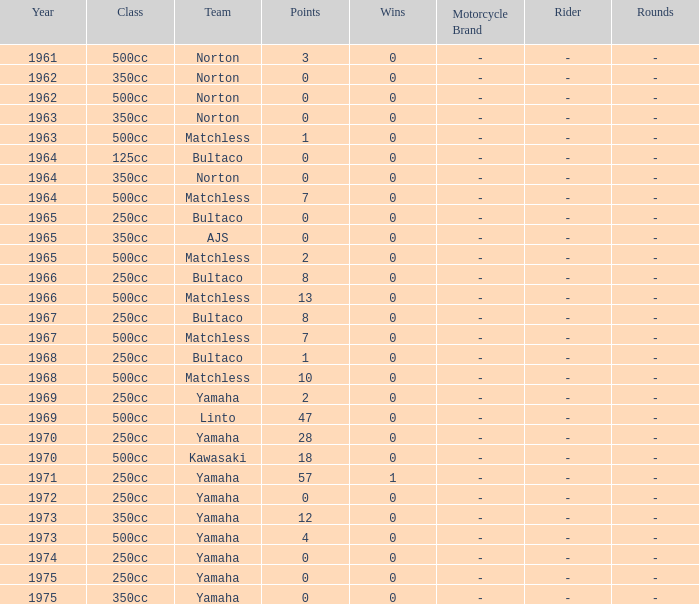What is the sum of all points in 1975 with 0 wins? None. Give me the full table as a dictionary. {'header': ['Year', 'Class', 'Team', 'Points', 'Wins', 'Motorcycle Brand', 'Rider', 'Rounds'], 'rows': [['1961', '500cc', 'Norton', '3', '0', '-', '-', '-'], ['1962', '350cc', 'Norton', '0', '0', '-', '-', '-'], ['1962', '500cc', 'Norton', '0', '0', '-', '-', '-'], ['1963', '350cc', 'Norton', '0', '0', '-', '-', '-'], ['1963', '500cc', 'Matchless', '1', '0', '-', '-', '-'], ['1964', '125cc', 'Bultaco', '0', '0', '-', '-', '-'], ['1964', '350cc', 'Norton', '0', '0', '-', '-', '-'], ['1964', '500cc', 'Matchless', '7', '0', '-', '-', '-'], ['1965', '250cc', 'Bultaco', '0', '0', '-', '-', '-'], ['1965', '350cc', 'AJS', '0', '0', '-', '-', '-'], ['1965', '500cc', 'Matchless', '2', '0', '-', '-', '-'], ['1966', '250cc', 'Bultaco', '8', '0', '-', '-', '-'], ['1966', '500cc', 'Matchless', '13', '0', '-', '-', '-'], ['1967', '250cc', 'Bultaco', '8', '0', '-', '-', '-'], ['1967', '500cc', 'Matchless', '7', '0', '-', '-', '-'], ['1968', '250cc', 'Bultaco', '1', '0', '-', '-', '-'], ['1968', '500cc', 'Matchless', '10', '0', '-', '-', '-'], ['1969', '250cc', 'Yamaha', '2', '0', '-', '-', '-'], ['1969', '500cc', 'Linto', '47', '0', '-', '-', '-'], ['1970', '250cc', 'Yamaha', '28', '0', '-', '-', '-'], ['1970', '500cc', 'Kawasaki', '18', '0', '-', '-', '-'], ['1971', '250cc', 'Yamaha', '57', '1', '-', '-', '-'], ['1972', '250cc', 'Yamaha', '0', '0', '-', '-', '-'], ['1973', '350cc', 'Yamaha', '12', '0', '-', '-', '-'], ['1973', '500cc', 'Yamaha', '4', '0', '-', '-', '-'], ['1974', '250cc', 'Yamaha', '0', '0', '-', '-', '-'], ['1975', '250cc', 'Yamaha', '0', '0', '-', '-', '-'], ['1975', '350cc', 'Yamaha', '0', '0', '-', '-', '-']]} 